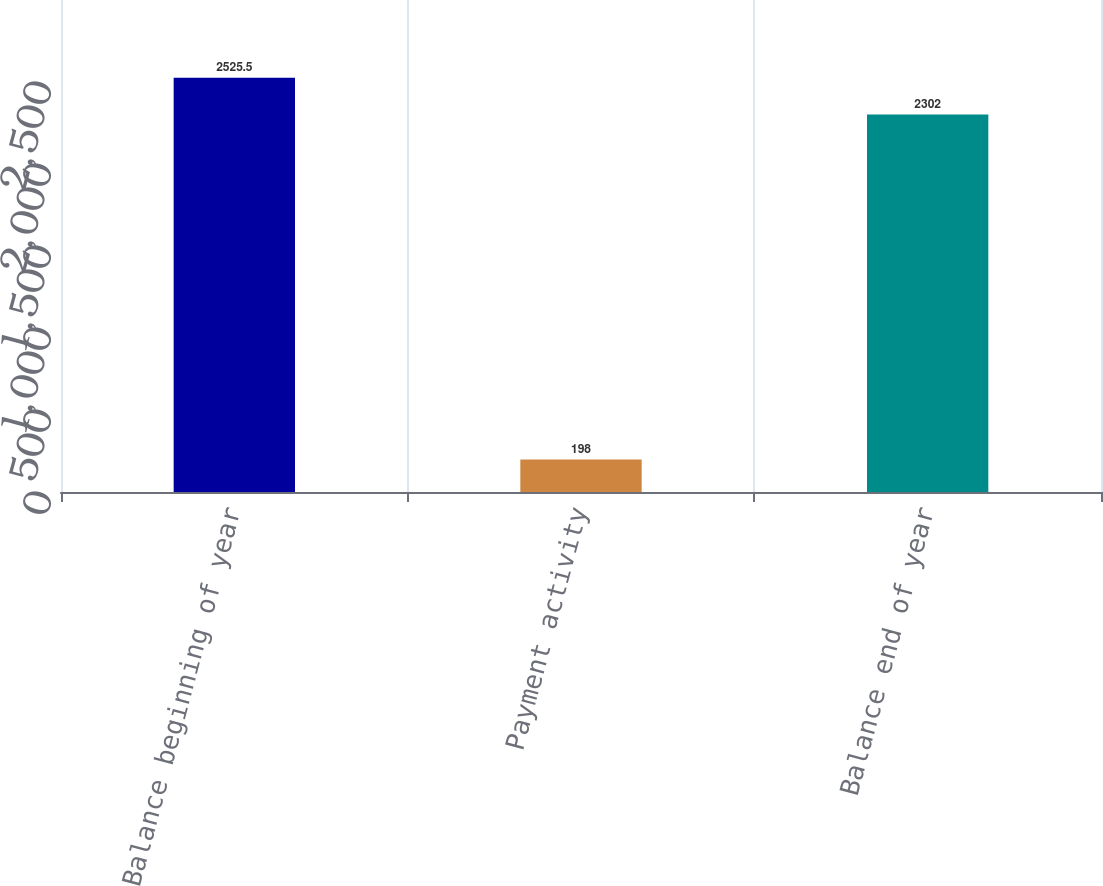Convert chart. <chart><loc_0><loc_0><loc_500><loc_500><bar_chart><fcel>Balance beginning of year<fcel>Payment activity<fcel>Balance end of year<nl><fcel>2525.5<fcel>198<fcel>2302<nl></chart> 